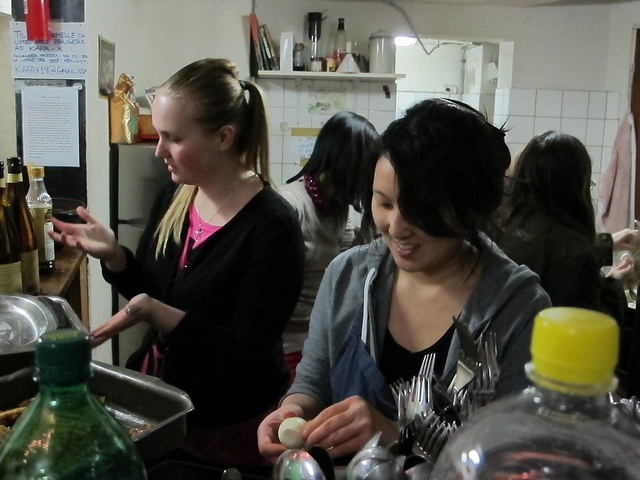Describe the objects in this image and their specific colors. I can see people in lightgray, black, maroon, gray, and darkgray tones, people in lightgray, black, gray, and maroon tones, bottle in lightgray, gray, olive, and black tones, people in lightgray, black, gray, darkgray, and olive tones, and bottle in lightgray, black, and darkgreen tones in this image. 